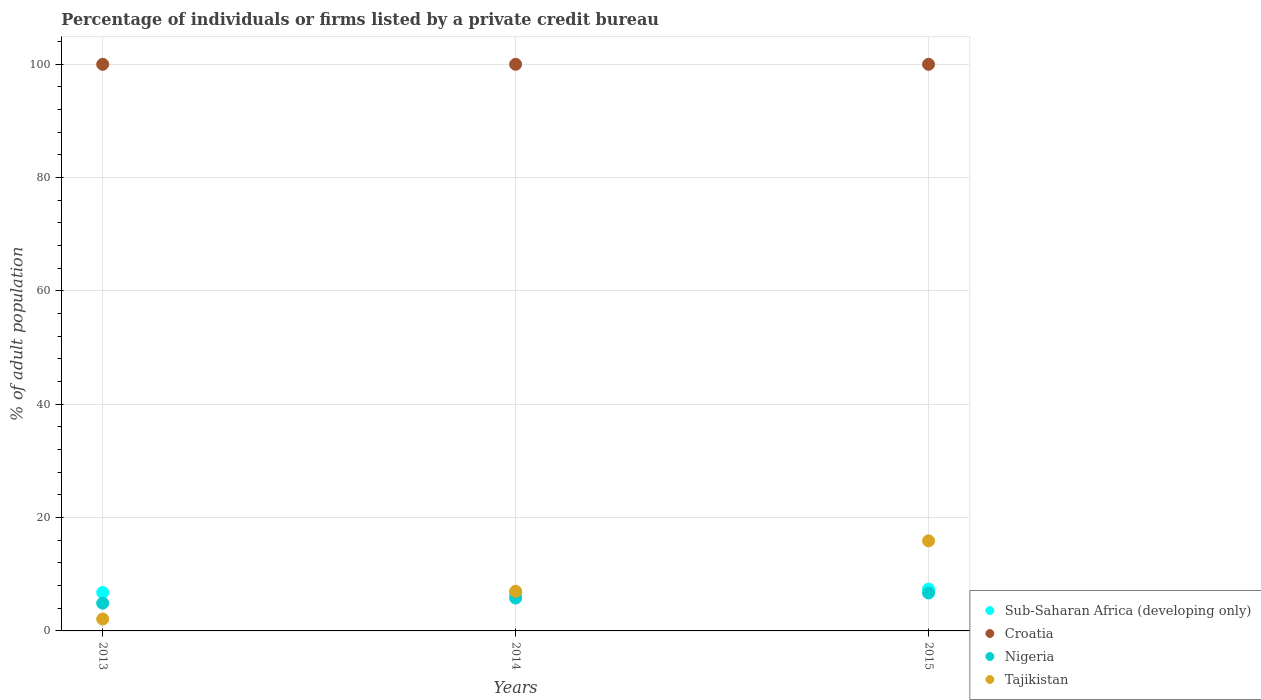Is the number of dotlines equal to the number of legend labels?
Provide a succinct answer. Yes. What is the percentage of population listed by a private credit bureau in Croatia in 2013?
Ensure brevity in your answer.  100. Across all years, what is the maximum percentage of population listed by a private credit bureau in Tajikistan?
Your answer should be compact. 15.9. Across all years, what is the minimum percentage of population listed by a private credit bureau in Sub-Saharan Africa (developing only)?
Give a very brief answer. 6.62. In which year was the percentage of population listed by a private credit bureau in Croatia maximum?
Offer a very short reply. 2013. In which year was the percentage of population listed by a private credit bureau in Tajikistan minimum?
Provide a short and direct response. 2013. What is the total percentage of population listed by a private credit bureau in Croatia in the graph?
Your response must be concise. 300. What is the difference between the percentage of population listed by a private credit bureau in Croatia in 2013 and the percentage of population listed by a private credit bureau in Nigeria in 2014?
Provide a succinct answer. 94.2. What is the average percentage of population listed by a private credit bureau in Sub-Saharan Africa (developing only) per year?
Offer a very short reply. 6.93. In the year 2014, what is the difference between the percentage of population listed by a private credit bureau in Tajikistan and percentage of population listed by a private credit bureau in Sub-Saharan Africa (developing only)?
Your answer should be very brief. 0.38. In how many years, is the percentage of population listed by a private credit bureau in Nigeria greater than 100 %?
Give a very brief answer. 0. What is the ratio of the percentage of population listed by a private credit bureau in Nigeria in 2013 to that in 2014?
Offer a terse response. 0.84. Is the percentage of population listed by a private credit bureau in Croatia in 2013 less than that in 2014?
Your response must be concise. No. Is the difference between the percentage of population listed by a private credit bureau in Tajikistan in 2013 and 2014 greater than the difference between the percentage of population listed by a private credit bureau in Sub-Saharan Africa (developing only) in 2013 and 2014?
Provide a succinct answer. No. What is the difference between the highest and the second highest percentage of population listed by a private credit bureau in Nigeria?
Keep it short and to the point. 0.9. What is the difference between the highest and the lowest percentage of population listed by a private credit bureau in Nigeria?
Your answer should be compact. 1.8. Is the sum of the percentage of population listed by a private credit bureau in Tajikistan in 2014 and 2015 greater than the maximum percentage of population listed by a private credit bureau in Croatia across all years?
Your answer should be compact. No. Is it the case that in every year, the sum of the percentage of population listed by a private credit bureau in Croatia and percentage of population listed by a private credit bureau in Sub-Saharan Africa (developing only)  is greater than the percentage of population listed by a private credit bureau in Nigeria?
Keep it short and to the point. Yes. Does the percentage of population listed by a private credit bureau in Nigeria monotonically increase over the years?
Give a very brief answer. Yes. How many dotlines are there?
Keep it short and to the point. 4. How many years are there in the graph?
Your answer should be compact. 3. Where does the legend appear in the graph?
Offer a terse response. Bottom right. What is the title of the graph?
Keep it short and to the point. Percentage of individuals or firms listed by a private credit bureau. What is the label or title of the Y-axis?
Keep it short and to the point. % of adult population. What is the % of adult population in Sub-Saharan Africa (developing only) in 2013?
Your answer should be very brief. 6.78. What is the % of adult population in Croatia in 2013?
Give a very brief answer. 100. What is the % of adult population of Nigeria in 2013?
Offer a very short reply. 4.9. What is the % of adult population of Tajikistan in 2013?
Make the answer very short. 2.1. What is the % of adult population in Sub-Saharan Africa (developing only) in 2014?
Your answer should be very brief. 6.62. What is the % of adult population in Nigeria in 2014?
Provide a succinct answer. 5.8. What is the % of adult population of Tajikistan in 2014?
Offer a terse response. 7. What is the % of adult population of Sub-Saharan Africa (developing only) in 2015?
Ensure brevity in your answer.  7.38. What is the % of adult population of Croatia in 2015?
Your answer should be very brief. 100. What is the % of adult population of Nigeria in 2015?
Your response must be concise. 6.7. Across all years, what is the maximum % of adult population in Sub-Saharan Africa (developing only)?
Make the answer very short. 7.38. Across all years, what is the maximum % of adult population in Nigeria?
Keep it short and to the point. 6.7. Across all years, what is the minimum % of adult population of Sub-Saharan Africa (developing only)?
Offer a terse response. 6.62. Across all years, what is the minimum % of adult population of Tajikistan?
Provide a succinct answer. 2.1. What is the total % of adult population of Sub-Saharan Africa (developing only) in the graph?
Give a very brief answer. 20.78. What is the total % of adult population of Croatia in the graph?
Make the answer very short. 300. What is the total % of adult population in Nigeria in the graph?
Keep it short and to the point. 17.4. What is the total % of adult population of Tajikistan in the graph?
Keep it short and to the point. 25. What is the difference between the % of adult population in Sub-Saharan Africa (developing only) in 2013 and that in 2014?
Keep it short and to the point. 0.16. What is the difference between the % of adult population of Croatia in 2013 and that in 2014?
Make the answer very short. 0. What is the difference between the % of adult population in Sub-Saharan Africa (developing only) in 2013 and that in 2015?
Offer a very short reply. -0.6. What is the difference between the % of adult population in Nigeria in 2013 and that in 2015?
Offer a terse response. -1.8. What is the difference between the % of adult population in Sub-Saharan Africa (developing only) in 2014 and that in 2015?
Your answer should be compact. -0.76. What is the difference between the % of adult population of Croatia in 2014 and that in 2015?
Your answer should be very brief. 0. What is the difference between the % of adult population in Tajikistan in 2014 and that in 2015?
Make the answer very short. -8.9. What is the difference between the % of adult population in Sub-Saharan Africa (developing only) in 2013 and the % of adult population in Croatia in 2014?
Offer a terse response. -93.22. What is the difference between the % of adult population of Sub-Saharan Africa (developing only) in 2013 and the % of adult population of Nigeria in 2014?
Your response must be concise. 0.98. What is the difference between the % of adult population of Sub-Saharan Africa (developing only) in 2013 and the % of adult population of Tajikistan in 2014?
Offer a terse response. -0.22. What is the difference between the % of adult population of Croatia in 2013 and the % of adult population of Nigeria in 2014?
Offer a very short reply. 94.2. What is the difference between the % of adult population in Croatia in 2013 and the % of adult population in Tajikistan in 2014?
Offer a very short reply. 93. What is the difference between the % of adult population in Nigeria in 2013 and the % of adult population in Tajikistan in 2014?
Offer a terse response. -2.1. What is the difference between the % of adult population in Sub-Saharan Africa (developing only) in 2013 and the % of adult population in Croatia in 2015?
Your response must be concise. -93.22. What is the difference between the % of adult population of Sub-Saharan Africa (developing only) in 2013 and the % of adult population of Nigeria in 2015?
Offer a very short reply. 0.08. What is the difference between the % of adult population in Sub-Saharan Africa (developing only) in 2013 and the % of adult population in Tajikistan in 2015?
Provide a short and direct response. -9.12. What is the difference between the % of adult population in Croatia in 2013 and the % of adult population in Nigeria in 2015?
Your answer should be very brief. 93.3. What is the difference between the % of adult population of Croatia in 2013 and the % of adult population of Tajikistan in 2015?
Ensure brevity in your answer.  84.1. What is the difference between the % of adult population of Nigeria in 2013 and the % of adult population of Tajikistan in 2015?
Ensure brevity in your answer.  -11. What is the difference between the % of adult population of Sub-Saharan Africa (developing only) in 2014 and the % of adult population of Croatia in 2015?
Provide a succinct answer. -93.38. What is the difference between the % of adult population of Sub-Saharan Africa (developing only) in 2014 and the % of adult population of Nigeria in 2015?
Make the answer very short. -0.08. What is the difference between the % of adult population in Sub-Saharan Africa (developing only) in 2014 and the % of adult population in Tajikistan in 2015?
Your response must be concise. -9.28. What is the difference between the % of adult population in Croatia in 2014 and the % of adult population in Nigeria in 2015?
Offer a very short reply. 93.3. What is the difference between the % of adult population in Croatia in 2014 and the % of adult population in Tajikistan in 2015?
Offer a very short reply. 84.1. What is the average % of adult population in Sub-Saharan Africa (developing only) per year?
Your answer should be very brief. 6.93. What is the average % of adult population in Nigeria per year?
Offer a terse response. 5.8. What is the average % of adult population in Tajikistan per year?
Ensure brevity in your answer.  8.33. In the year 2013, what is the difference between the % of adult population of Sub-Saharan Africa (developing only) and % of adult population of Croatia?
Give a very brief answer. -93.22. In the year 2013, what is the difference between the % of adult population of Sub-Saharan Africa (developing only) and % of adult population of Nigeria?
Your answer should be compact. 1.88. In the year 2013, what is the difference between the % of adult population in Sub-Saharan Africa (developing only) and % of adult population in Tajikistan?
Keep it short and to the point. 4.68. In the year 2013, what is the difference between the % of adult population of Croatia and % of adult population of Nigeria?
Your response must be concise. 95.1. In the year 2013, what is the difference between the % of adult population of Croatia and % of adult population of Tajikistan?
Provide a succinct answer. 97.9. In the year 2013, what is the difference between the % of adult population in Nigeria and % of adult population in Tajikistan?
Offer a terse response. 2.8. In the year 2014, what is the difference between the % of adult population in Sub-Saharan Africa (developing only) and % of adult population in Croatia?
Provide a succinct answer. -93.38. In the year 2014, what is the difference between the % of adult population of Sub-Saharan Africa (developing only) and % of adult population of Nigeria?
Offer a terse response. 0.82. In the year 2014, what is the difference between the % of adult population of Sub-Saharan Africa (developing only) and % of adult population of Tajikistan?
Make the answer very short. -0.38. In the year 2014, what is the difference between the % of adult population of Croatia and % of adult population of Nigeria?
Provide a succinct answer. 94.2. In the year 2014, what is the difference between the % of adult population in Croatia and % of adult population in Tajikistan?
Keep it short and to the point. 93. In the year 2014, what is the difference between the % of adult population of Nigeria and % of adult population of Tajikistan?
Keep it short and to the point. -1.2. In the year 2015, what is the difference between the % of adult population of Sub-Saharan Africa (developing only) and % of adult population of Croatia?
Your answer should be compact. -92.62. In the year 2015, what is the difference between the % of adult population in Sub-Saharan Africa (developing only) and % of adult population in Nigeria?
Provide a succinct answer. 0.68. In the year 2015, what is the difference between the % of adult population of Sub-Saharan Africa (developing only) and % of adult population of Tajikistan?
Offer a very short reply. -8.52. In the year 2015, what is the difference between the % of adult population in Croatia and % of adult population in Nigeria?
Offer a terse response. 93.3. In the year 2015, what is the difference between the % of adult population of Croatia and % of adult population of Tajikistan?
Offer a very short reply. 84.1. In the year 2015, what is the difference between the % of adult population of Nigeria and % of adult population of Tajikistan?
Keep it short and to the point. -9.2. What is the ratio of the % of adult population of Sub-Saharan Africa (developing only) in 2013 to that in 2014?
Your answer should be very brief. 1.02. What is the ratio of the % of adult population of Nigeria in 2013 to that in 2014?
Your response must be concise. 0.84. What is the ratio of the % of adult population in Sub-Saharan Africa (developing only) in 2013 to that in 2015?
Provide a succinct answer. 0.92. What is the ratio of the % of adult population of Croatia in 2013 to that in 2015?
Offer a very short reply. 1. What is the ratio of the % of adult population in Nigeria in 2013 to that in 2015?
Give a very brief answer. 0.73. What is the ratio of the % of adult population in Tajikistan in 2013 to that in 2015?
Make the answer very short. 0.13. What is the ratio of the % of adult population in Sub-Saharan Africa (developing only) in 2014 to that in 2015?
Provide a succinct answer. 0.9. What is the ratio of the % of adult population in Nigeria in 2014 to that in 2015?
Your response must be concise. 0.87. What is the ratio of the % of adult population in Tajikistan in 2014 to that in 2015?
Offer a terse response. 0.44. What is the difference between the highest and the second highest % of adult population of Sub-Saharan Africa (developing only)?
Offer a very short reply. 0.6. What is the difference between the highest and the lowest % of adult population in Sub-Saharan Africa (developing only)?
Provide a short and direct response. 0.76. What is the difference between the highest and the lowest % of adult population in Croatia?
Keep it short and to the point. 0. What is the difference between the highest and the lowest % of adult population of Tajikistan?
Your answer should be compact. 13.8. 